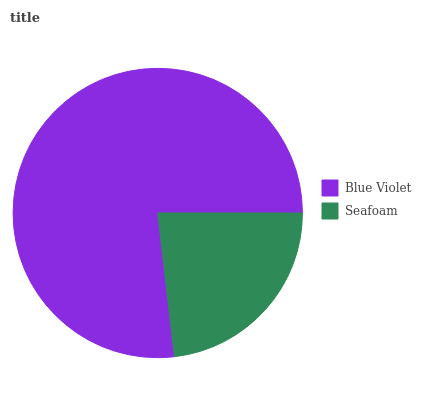Is Seafoam the minimum?
Answer yes or no. Yes. Is Blue Violet the maximum?
Answer yes or no. Yes. Is Seafoam the maximum?
Answer yes or no. No. Is Blue Violet greater than Seafoam?
Answer yes or no. Yes. Is Seafoam less than Blue Violet?
Answer yes or no. Yes. Is Seafoam greater than Blue Violet?
Answer yes or no. No. Is Blue Violet less than Seafoam?
Answer yes or no. No. Is Blue Violet the high median?
Answer yes or no. Yes. Is Seafoam the low median?
Answer yes or no. Yes. Is Seafoam the high median?
Answer yes or no. No. Is Blue Violet the low median?
Answer yes or no. No. 